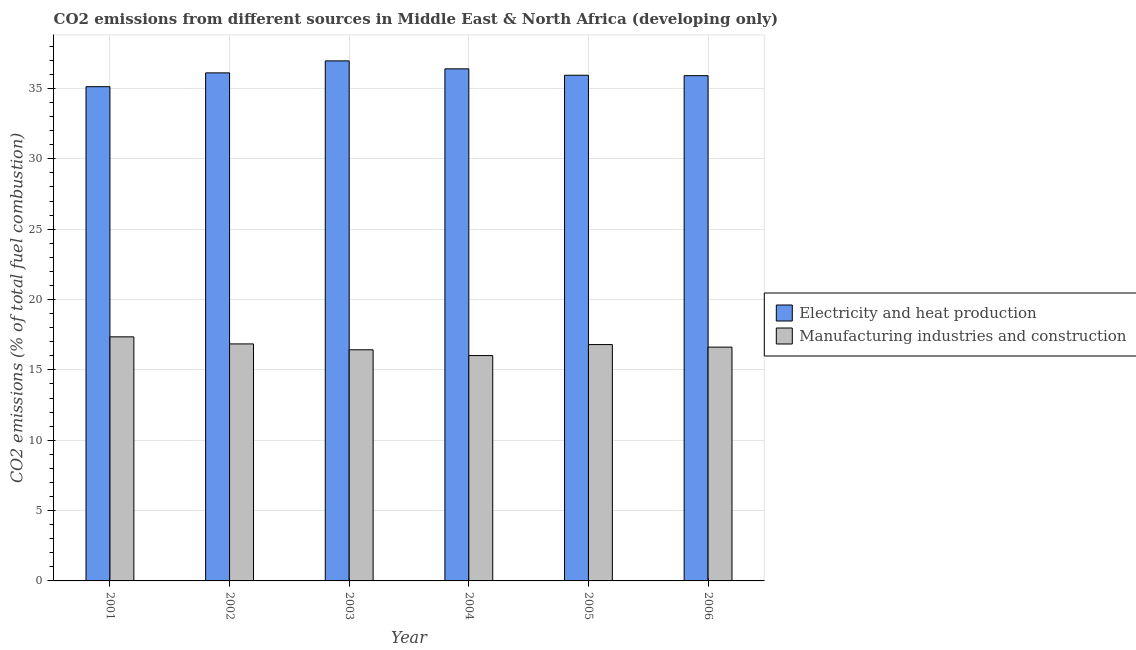How many bars are there on the 3rd tick from the left?
Your answer should be compact. 2. What is the co2 emissions due to electricity and heat production in 2001?
Offer a terse response. 35.13. Across all years, what is the maximum co2 emissions due to electricity and heat production?
Keep it short and to the point. 36.96. Across all years, what is the minimum co2 emissions due to electricity and heat production?
Make the answer very short. 35.13. In which year was the co2 emissions due to manufacturing industries maximum?
Give a very brief answer. 2001. In which year was the co2 emissions due to manufacturing industries minimum?
Your response must be concise. 2004. What is the total co2 emissions due to manufacturing industries in the graph?
Your answer should be very brief. 100.05. What is the difference between the co2 emissions due to manufacturing industries in 2001 and that in 2005?
Your answer should be very brief. 0.55. What is the difference between the co2 emissions due to manufacturing industries in 2004 and the co2 emissions due to electricity and heat production in 2002?
Your answer should be compact. -0.83. What is the average co2 emissions due to manufacturing industries per year?
Ensure brevity in your answer.  16.68. In the year 2002, what is the difference between the co2 emissions due to manufacturing industries and co2 emissions due to electricity and heat production?
Offer a terse response. 0. What is the ratio of the co2 emissions due to electricity and heat production in 2003 to that in 2004?
Give a very brief answer. 1.02. What is the difference between the highest and the second highest co2 emissions due to electricity and heat production?
Provide a succinct answer. 0.57. What is the difference between the highest and the lowest co2 emissions due to electricity and heat production?
Provide a succinct answer. 1.83. Is the sum of the co2 emissions due to manufacturing industries in 2001 and 2002 greater than the maximum co2 emissions due to electricity and heat production across all years?
Offer a terse response. Yes. What does the 2nd bar from the left in 2005 represents?
Provide a short and direct response. Manufacturing industries and construction. What does the 2nd bar from the right in 2004 represents?
Your answer should be very brief. Electricity and heat production. How many years are there in the graph?
Your response must be concise. 6. Are the values on the major ticks of Y-axis written in scientific E-notation?
Provide a short and direct response. No. Does the graph contain any zero values?
Your response must be concise. No. Does the graph contain grids?
Make the answer very short. Yes. How many legend labels are there?
Keep it short and to the point. 2. What is the title of the graph?
Your response must be concise. CO2 emissions from different sources in Middle East & North Africa (developing only). What is the label or title of the Y-axis?
Keep it short and to the point. CO2 emissions (% of total fuel combustion). What is the CO2 emissions (% of total fuel combustion) in Electricity and heat production in 2001?
Make the answer very short. 35.13. What is the CO2 emissions (% of total fuel combustion) of Manufacturing industries and construction in 2001?
Your answer should be compact. 17.35. What is the CO2 emissions (% of total fuel combustion) in Electricity and heat production in 2002?
Offer a very short reply. 36.11. What is the CO2 emissions (% of total fuel combustion) in Manufacturing industries and construction in 2002?
Your response must be concise. 16.85. What is the CO2 emissions (% of total fuel combustion) of Electricity and heat production in 2003?
Your response must be concise. 36.96. What is the CO2 emissions (% of total fuel combustion) of Manufacturing industries and construction in 2003?
Ensure brevity in your answer.  16.43. What is the CO2 emissions (% of total fuel combustion) in Electricity and heat production in 2004?
Your answer should be compact. 36.4. What is the CO2 emissions (% of total fuel combustion) of Manufacturing industries and construction in 2004?
Make the answer very short. 16.02. What is the CO2 emissions (% of total fuel combustion) in Electricity and heat production in 2005?
Provide a succinct answer. 35.94. What is the CO2 emissions (% of total fuel combustion) of Manufacturing industries and construction in 2005?
Make the answer very short. 16.8. What is the CO2 emissions (% of total fuel combustion) of Electricity and heat production in 2006?
Offer a very short reply. 35.91. What is the CO2 emissions (% of total fuel combustion) of Manufacturing industries and construction in 2006?
Your answer should be very brief. 16.62. Across all years, what is the maximum CO2 emissions (% of total fuel combustion) of Electricity and heat production?
Make the answer very short. 36.96. Across all years, what is the maximum CO2 emissions (% of total fuel combustion) in Manufacturing industries and construction?
Give a very brief answer. 17.35. Across all years, what is the minimum CO2 emissions (% of total fuel combustion) of Electricity and heat production?
Provide a short and direct response. 35.13. Across all years, what is the minimum CO2 emissions (% of total fuel combustion) of Manufacturing industries and construction?
Keep it short and to the point. 16.02. What is the total CO2 emissions (% of total fuel combustion) in Electricity and heat production in the graph?
Give a very brief answer. 216.44. What is the total CO2 emissions (% of total fuel combustion) of Manufacturing industries and construction in the graph?
Your answer should be compact. 100.05. What is the difference between the CO2 emissions (% of total fuel combustion) of Electricity and heat production in 2001 and that in 2002?
Offer a terse response. -0.98. What is the difference between the CO2 emissions (% of total fuel combustion) of Manufacturing industries and construction in 2001 and that in 2002?
Offer a very short reply. 0.5. What is the difference between the CO2 emissions (% of total fuel combustion) of Electricity and heat production in 2001 and that in 2003?
Make the answer very short. -1.83. What is the difference between the CO2 emissions (% of total fuel combustion) of Manufacturing industries and construction in 2001 and that in 2003?
Your answer should be compact. 0.92. What is the difference between the CO2 emissions (% of total fuel combustion) of Electricity and heat production in 2001 and that in 2004?
Provide a short and direct response. -1.27. What is the difference between the CO2 emissions (% of total fuel combustion) in Manufacturing industries and construction in 2001 and that in 2004?
Ensure brevity in your answer.  1.33. What is the difference between the CO2 emissions (% of total fuel combustion) of Electricity and heat production in 2001 and that in 2005?
Ensure brevity in your answer.  -0.81. What is the difference between the CO2 emissions (% of total fuel combustion) of Manufacturing industries and construction in 2001 and that in 2005?
Provide a short and direct response. 0.55. What is the difference between the CO2 emissions (% of total fuel combustion) of Electricity and heat production in 2001 and that in 2006?
Keep it short and to the point. -0.78. What is the difference between the CO2 emissions (% of total fuel combustion) in Manufacturing industries and construction in 2001 and that in 2006?
Ensure brevity in your answer.  0.73. What is the difference between the CO2 emissions (% of total fuel combustion) in Electricity and heat production in 2002 and that in 2003?
Ensure brevity in your answer.  -0.85. What is the difference between the CO2 emissions (% of total fuel combustion) of Manufacturing industries and construction in 2002 and that in 2003?
Keep it short and to the point. 0.42. What is the difference between the CO2 emissions (% of total fuel combustion) in Electricity and heat production in 2002 and that in 2004?
Your answer should be compact. -0.29. What is the difference between the CO2 emissions (% of total fuel combustion) in Manufacturing industries and construction in 2002 and that in 2004?
Provide a succinct answer. 0.83. What is the difference between the CO2 emissions (% of total fuel combustion) of Electricity and heat production in 2002 and that in 2005?
Offer a very short reply. 0.17. What is the difference between the CO2 emissions (% of total fuel combustion) in Manufacturing industries and construction in 2002 and that in 2005?
Ensure brevity in your answer.  0.05. What is the difference between the CO2 emissions (% of total fuel combustion) in Electricity and heat production in 2002 and that in 2006?
Provide a succinct answer. 0.2. What is the difference between the CO2 emissions (% of total fuel combustion) in Manufacturing industries and construction in 2002 and that in 2006?
Provide a short and direct response. 0.23. What is the difference between the CO2 emissions (% of total fuel combustion) of Electricity and heat production in 2003 and that in 2004?
Your answer should be compact. 0.57. What is the difference between the CO2 emissions (% of total fuel combustion) in Manufacturing industries and construction in 2003 and that in 2004?
Your answer should be compact. 0.41. What is the difference between the CO2 emissions (% of total fuel combustion) in Electricity and heat production in 2003 and that in 2005?
Your response must be concise. 1.02. What is the difference between the CO2 emissions (% of total fuel combustion) of Manufacturing industries and construction in 2003 and that in 2005?
Ensure brevity in your answer.  -0.37. What is the difference between the CO2 emissions (% of total fuel combustion) in Electricity and heat production in 2003 and that in 2006?
Keep it short and to the point. 1.05. What is the difference between the CO2 emissions (% of total fuel combustion) in Manufacturing industries and construction in 2003 and that in 2006?
Offer a terse response. -0.19. What is the difference between the CO2 emissions (% of total fuel combustion) of Electricity and heat production in 2004 and that in 2005?
Make the answer very short. 0.46. What is the difference between the CO2 emissions (% of total fuel combustion) in Manufacturing industries and construction in 2004 and that in 2005?
Provide a short and direct response. -0.78. What is the difference between the CO2 emissions (% of total fuel combustion) in Electricity and heat production in 2004 and that in 2006?
Provide a short and direct response. 0.49. What is the difference between the CO2 emissions (% of total fuel combustion) in Manufacturing industries and construction in 2004 and that in 2006?
Offer a very short reply. -0.6. What is the difference between the CO2 emissions (% of total fuel combustion) in Electricity and heat production in 2005 and that in 2006?
Give a very brief answer. 0.03. What is the difference between the CO2 emissions (% of total fuel combustion) in Manufacturing industries and construction in 2005 and that in 2006?
Offer a very short reply. 0.18. What is the difference between the CO2 emissions (% of total fuel combustion) in Electricity and heat production in 2001 and the CO2 emissions (% of total fuel combustion) in Manufacturing industries and construction in 2002?
Your answer should be very brief. 18.28. What is the difference between the CO2 emissions (% of total fuel combustion) of Electricity and heat production in 2001 and the CO2 emissions (% of total fuel combustion) of Manufacturing industries and construction in 2003?
Make the answer very short. 18.7. What is the difference between the CO2 emissions (% of total fuel combustion) of Electricity and heat production in 2001 and the CO2 emissions (% of total fuel combustion) of Manufacturing industries and construction in 2004?
Your response must be concise. 19.11. What is the difference between the CO2 emissions (% of total fuel combustion) in Electricity and heat production in 2001 and the CO2 emissions (% of total fuel combustion) in Manufacturing industries and construction in 2005?
Your response must be concise. 18.33. What is the difference between the CO2 emissions (% of total fuel combustion) of Electricity and heat production in 2001 and the CO2 emissions (% of total fuel combustion) of Manufacturing industries and construction in 2006?
Your answer should be compact. 18.51. What is the difference between the CO2 emissions (% of total fuel combustion) in Electricity and heat production in 2002 and the CO2 emissions (% of total fuel combustion) in Manufacturing industries and construction in 2003?
Offer a terse response. 19.68. What is the difference between the CO2 emissions (% of total fuel combustion) in Electricity and heat production in 2002 and the CO2 emissions (% of total fuel combustion) in Manufacturing industries and construction in 2004?
Provide a succinct answer. 20.09. What is the difference between the CO2 emissions (% of total fuel combustion) in Electricity and heat production in 2002 and the CO2 emissions (% of total fuel combustion) in Manufacturing industries and construction in 2005?
Ensure brevity in your answer.  19.31. What is the difference between the CO2 emissions (% of total fuel combustion) of Electricity and heat production in 2002 and the CO2 emissions (% of total fuel combustion) of Manufacturing industries and construction in 2006?
Your answer should be very brief. 19.49. What is the difference between the CO2 emissions (% of total fuel combustion) in Electricity and heat production in 2003 and the CO2 emissions (% of total fuel combustion) in Manufacturing industries and construction in 2004?
Provide a short and direct response. 20.94. What is the difference between the CO2 emissions (% of total fuel combustion) of Electricity and heat production in 2003 and the CO2 emissions (% of total fuel combustion) of Manufacturing industries and construction in 2005?
Make the answer very short. 20.16. What is the difference between the CO2 emissions (% of total fuel combustion) in Electricity and heat production in 2003 and the CO2 emissions (% of total fuel combustion) in Manufacturing industries and construction in 2006?
Offer a terse response. 20.34. What is the difference between the CO2 emissions (% of total fuel combustion) of Electricity and heat production in 2004 and the CO2 emissions (% of total fuel combustion) of Manufacturing industries and construction in 2005?
Provide a succinct answer. 19.6. What is the difference between the CO2 emissions (% of total fuel combustion) in Electricity and heat production in 2004 and the CO2 emissions (% of total fuel combustion) in Manufacturing industries and construction in 2006?
Your answer should be very brief. 19.78. What is the difference between the CO2 emissions (% of total fuel combustion) in Electricity and heat production in 2005 and the CO2 emissions (% of total fuel combustion) in Manufacturing industries and construction in 2006?
Give a very brief answer. 19.32. What is the average CO2 emissions (% of total fuel combustion) in Electricity and heat production per year?
Your answer should be very brief. 36.07. What is the average CO2 emissions (% of total fuel combustion) in Manufacturing industries and construction per year?
Your response must be concise. 16.68. In the year 2001, what is the difference between the CO2 emissions (% of total fuel combustion) of Electricity and heat production and CO2 emissions (% of total fuel combustion) of Manufacturing industries and construction?
Give a very brief answer. 17.78. In the year 2002, what is the difference between the CO2 emissions (% of total fuel combustion) in Electricity and heat production and CO2 emissions (% of total fuel combustion) in Manufacturing industries and construction?
Offer a very short reply. 19.26. In the year 2003, what is the difference between the CO2 emissions (% of total fuel combustion) of Electricity and heat production and CO2 emissions (% of total fuel combustion) of Manufacturing industries and construction?
Provide a short and direct response. 20.53. In the year 2004, what is the difference between the CO2 emissions (% of total fuel combustion) of Electricity and heat production and CO2 emissions (% of total fuel combustion) of Manufacturing industries and construction?
Give a very brief answer. 20.38. In the year 2005, what is the difference between the CO2 emissions (% of total fuel combustion) in Electricity and heat production and CO2 emissions (% of total fuel combustion) in Manufacturing industries and construction?
Provide a succinct answer. 19.14. In the year 2006, what is the difference between the CO2 emissions (% of total fuel combustion) of Electricity and heat production and CO2 emissions (% of total fuel combustion) of Manufacturing industries and construction?
Provide a succinct answer. 19.29. What is the ratio of the CO2 emissions (% of total fuel combustion) in Electricity and heat production in 2001 to that in 2002?
Provide a succinct answer. 0.97. What is the ratio of the CO2 emissions (% of total fuel combustion) in Manufacturing industries and construction in 2001 to that in 2002?
Offer a very short reply. 1.03. What is the ratio of the CO2 emissions (% of total fuel combustion) in Electricity and heat production in 2001 to that in 2003?
Your answer should be compact. 0.95. What is the ratio of the CO2 emissions (% of total fuel combustion) in Manufacturing industries and construction in 2001 to that in 2003?
Make the answer very short. 1.06. What is the ratio of the CO2 emissions (% of total fuel combustion) in Electricity and heat production in 2001 to that in 2004?
Offer a terse response. 0.97. What is the ratio of the CO2 emissions (% of total fuel combustion) of Manufacturing industries and construction in 2001 to that in 2004?
Keep it short and to the point. 1.08. What is the ratio of the CO2 emissions (% of total fuel combustion) in Electricity and heat production in 2001 to that in 2005?
Keep it short and to the point. 0.98. What is the ratio of the CO2 emissions (% of total fuel combustion) of Manufacturing industries and construction in 2001 to that in 2005?
Provide a short and direct response. 1.03. What is the ratio of the CO2 emissions (% of total fuel combustion) in Electricity and heat production in 2001 to that in 2006?
Your answer should be very brief. 0.98. What is the ratio of the CO2 emissions (% of total fuel combustion) in Manufacturing industries and construction in 2001 to that in 2006?
Ensure brevity in your answer.  1.04. What is the ratio of the CO2 emissions (% of total fuel combustion) in Electricity and heat production in 2002 to that in 2003?
Keep it short and to the point. 0.98. What is the ratio of the CO2 emissions (% of total fuel combustion) in Manufacturing industries and construction in 2002 to that in 2003?
Offer a very short reply. 1.03. What is the ratio of the CO2 emissions (% of total fuel combustion) in Manufacturing industries and construction in 2002 to that in 2004?
Provide a short and direct response. 1.05. What is the ratio of the CO2 emissions (% of total fuel combustion) in Electricity and heat production in 2002 to that in 2006?
Keep it short and to the point. 1.01. What is the ratio of the CO2 emissions (% of total fuel combustion) of Manufacturing industries and construction in 2002 to that in 2006?
Offer a very short reply. 1.01. What is the ratio of the CO2 emissions (% of total fuel combustion) in Electricity and heat production in 2003 to that in 2004?
Provide a succinct answer. 1.02. What is the ratio of the CO2 emissions (% of total fuel combustion) of Manufacturing industries and construction in 2003 to that in 2004?
Provide a succinct answer. 1.03. What is the ratio of the CO2 emissions (% of total fuel combustion) in Electricity and heat production in 2003 to that in 2005?
Your response must be concise. 1.03. What is the ratio of the CO2 emissions (% of total fuel combustion) of Manufacturing industries and construction in 2003 to that in 2005?
Make the answer very short. 0.98. What is the ratio of the CO2 emissions (% of total fuel combustion) in Electricity and heat production in 2003 to that in 2006?
Ensure brevity in your answer.  1.03. What is the ratio of the CO2 emissions (% of total fuel combustion) in Manufacturing industries and construction in 2003 to that in 2006?
Offer a very short reply. 0.99. What is the ratio of the CO2 emissions (% of total fuel combustion) of Electricity and heat production in 2004 to that in 2005?
Your response must be concise. 1.01. What is the ratio of the CO2 emissions (% of total fuel combustion) of Manufacturing industries and construction in 2004 to that in 2005?
Keep it short and to the point. 0.95. What is the ratio of the CO2 emissions (% of total fuel combustion) of Electricity and heat production in 2004 to that in 2006?
Provide a short and direct response. 1.01. What is the ratio of the CO2 emissions (% of total fuel combustion) of Manufacturing industries and construction in 2004 to that in 2006?
Keep it short and to the point. 0.96. What is the ratio of the CO2 emissions (% of total fuel combustion) of Electricity and heat production in 2005 to that in 2006?
Your answer should be very brief. 1. What is the ratio of the CO2 emissions (% of total fuel combustion) in Manufacturing industries and construction in 2005 to that in 2006?
Ensure brevity in your answer.  1.01. What is the difference between the highest and the second highest CO2 emissions (% of total fuel combustion) in Electricity and heat production?
Your answer should be compact. 0.57. What is the difference between the highest and the second highest CO2 emissions (% of total fuel combustion) in Manufacturing industries and construction?
Offer a very short reply. 0.5. What is the difference between the highest and the lowest CO2 emissions (% of total fuel combustion) of Electricity and heat production?
Provide a short and direct response. 1.83. What is the difference between the highest and the lowest CO2 emissions (% of total fuel combustion) in Manufacturing industries and construction?
Ensure brevity in your answer.  1.33. 